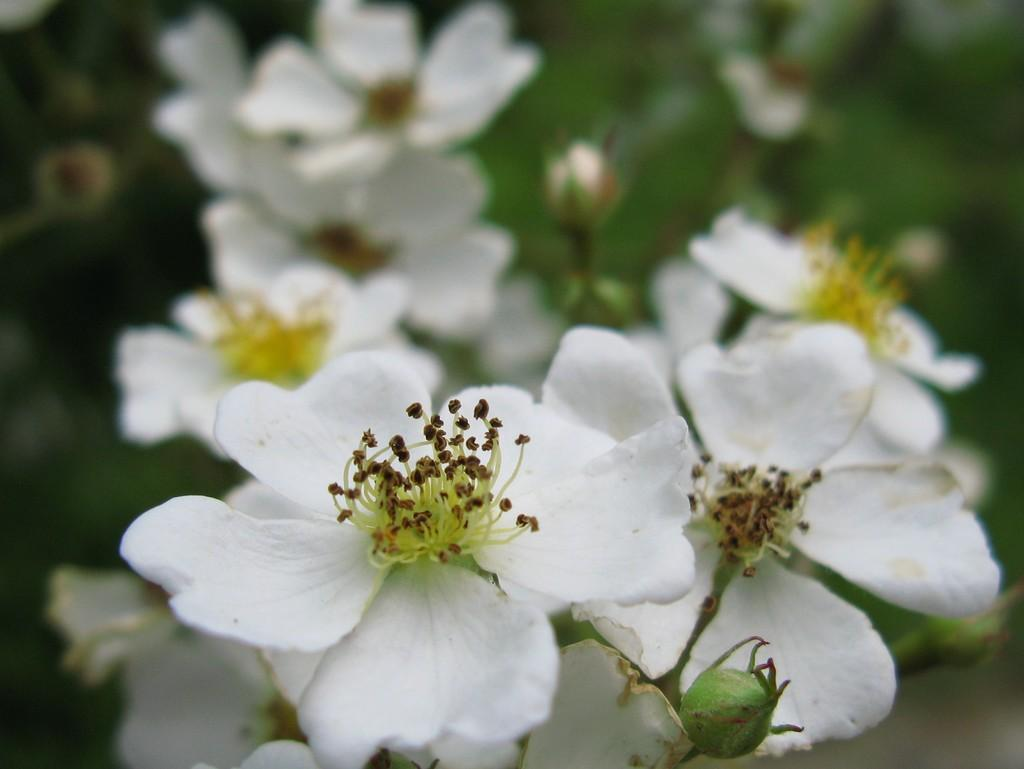What type of living organisms are in the image? There are plants in the image. What color are the flowers on the plants? The flowers on the plants are white. Can you describe the background of the image? The background of the image is blurred. Can you tell me how many ants are crawling on the self in the image? There are no ants or self present in the image; it features plants with white flowers and a blurred background. 